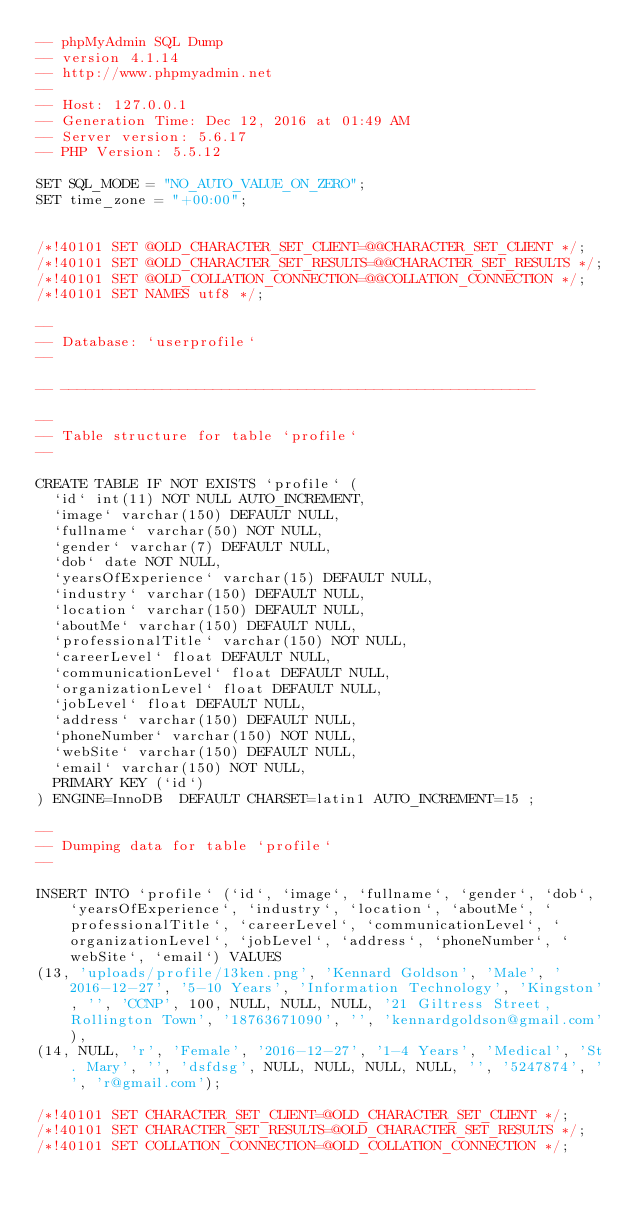<code> <loc_0><loc_0><loc_500><loc_500><_SQL_>-- phpMyAdmin SQL Dump
-- version 4.1.14
-- http://www.phpmyadmin.net
--
-- Host: 127.0.0.1
-- Generation Time: Dec 12, 2016 at 01:49 AM
-- Server version: 5.6.17
-- PHP Version: 5.5.12

SET SQL_MODE = "NO_AUTO_VALUE_ON_ZERO";
SET time_zone = "+00:00";


/*!40101 SET @OLD_CHARACTER_SET_CLIENT=@@CHARACTER_SET_CLIENT */;
/*!40101 SET @OLD_CHARACTER_SET_RESULTS=@@CHARACTER_SET_RESULTS */;
/*!40101 SET @OLD_COLLATION_CONNECTION=@@COLLATION_CONNECTION */;
/*!40101 SET NAMES utf8 */;

--
-- Database: `userprofile`
--

-- --------------------------------------------------------

--
-- Table structure for table `profile`
--

CREATE TABLE IF NOT EXISTS `profile` (
  `id` int(11) NOT NULL AUTO_INCREMENT,
  `image` varchar(150) DEFAULT NULL,
  `fullname` varchar(50) NOT NULL,
  `gender` varchar(7) DEFAULT NULL,
  `dob` date NOT NULL,
  `yearsOfExperience` varchar(15) DEFAULT NULL,
  `industry` varchar(150) DEFAULT NULL,
  `location` varchar(150) DEFAULT NULL,
  `aboutMe` varchar(150) DEFAULT NULL,
  `professionalTitle` varchar(150) NOT NULL,
  `careerLevel` float DEFAULT NULL,
  `communicationLevel` float DEFAULT NULL,
  `organizationLevel` float DEFAULT NULL,
  `jobLevel` float DEFAULT NULL,
  `address` varchar(150) DEFAULT NULL,
  `phoneNumber` varchar(150) NOT NULL,
  `webSite` varchar(150) DEFAULT NULL,
  `email` varchar(150) NOT NULL,
  PRIMARY KEY (`id`)
) ENGINE=InnoDB  DEFAULT CHARSET=latin1 AUTO_INCREMENT=15 ;

--
-- Dumping data for table `profile`
--

INSERT INTO `profile` (`id`, `image`, `fullname`, `gender`, `dob`, `yearsOfExperience`, `industry`, `location`, `aboutMe`, `professionalTitle`, `careerLevel`, `communicationLevel`, `organizationLevel`, `jobLevel`, `address`, `phoneNumber`, `webSite`, `email`) VALUES
(13, 'uploads/profile/13ken.png', 'Kennard Goldson', 'Male', '2016-12-27', '5-10 Years', 'Information Technology', 'Kingston', '', 'CCNP', 100, NULL, NULL, NULL, '21 Giltress Street, Rollington Town', '18763671090', '', 'kennardgoldson@gmail.com'),
(14, NULL, 'r', 'Female', '2016-12-27', '1-4 Years', 'Medical', 'St. Mary', '', 'dsfdsg', NULL, NULL, NULL, NULL, '', '5247874', '', 'r@gmail.com');

/*!40101 SET CHARACTER_SET_CLIENT=@OLD_CHARACTER_SET_CLIENT */;
/*!40101 SET CHARACTER_SET_RESULTS=@OLD_CHARACTER_SET_RESULTS */;
/*!40101 SET COLLATION_CONNECTION=@OLD_COLLATION_CONNECTION */;
</code> 